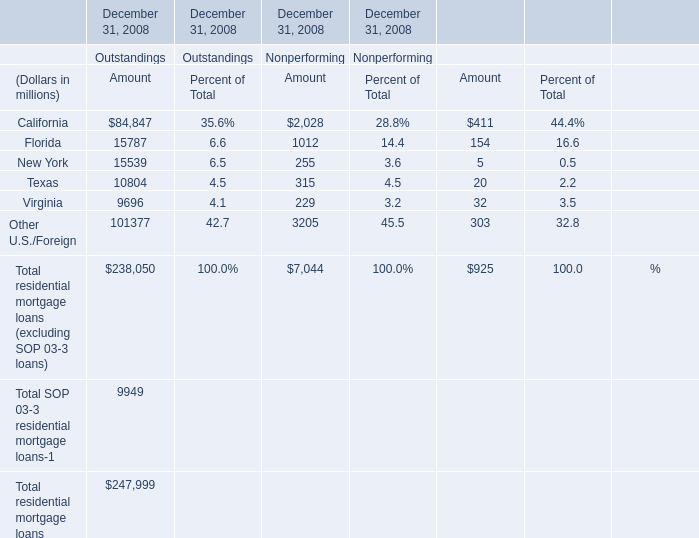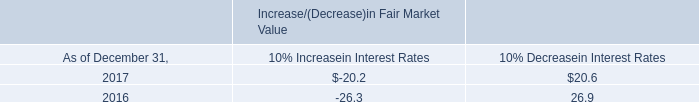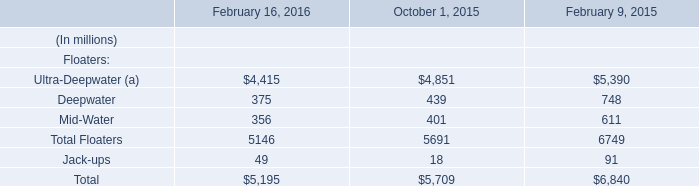what is the growth rate in the interest income in 2017 relative to 2016? 
Computations: ((19.4 - 20.1) / 20.1)
Answer: -0.03483. what was the average interest income from 2016 and 2017 , in millions? 
Computations: ((19.4 + 20.1) / 2)
Answer: 19.75. 